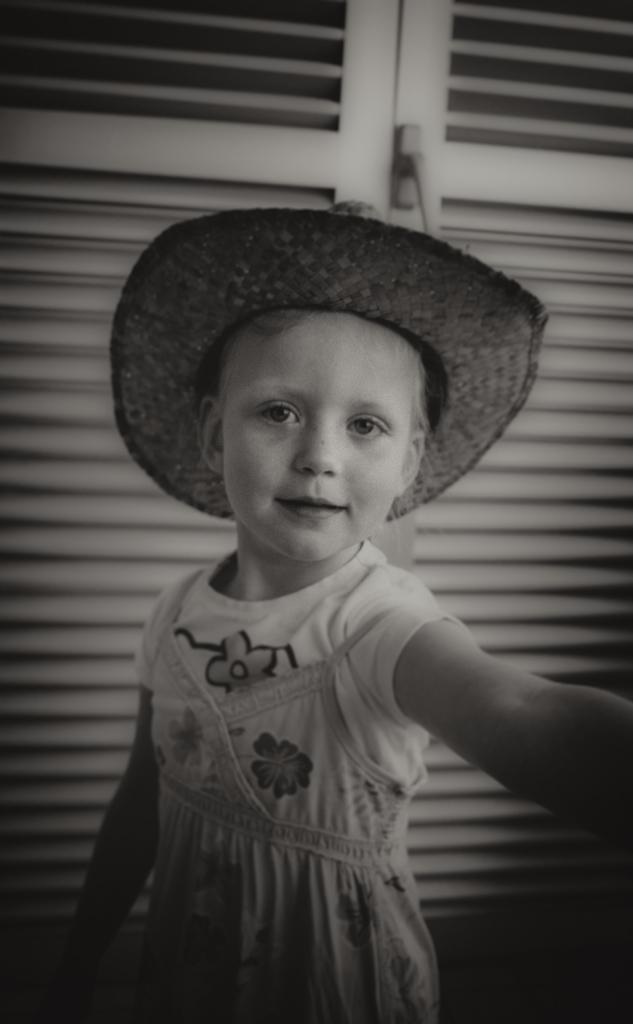What is the color scheme of the image? The image is black and white. Who or what is the main subject of the image? There is a child in the image. What is the child wearing? The child is wearing clothes and a hat. What type of door can be seen in the image? There is a wood door in the image. Is there a kitten playing with sleet in the image? There is no kitten or sleet present in the image. What type of crib is visible in the image? There is no crib present in the image. 